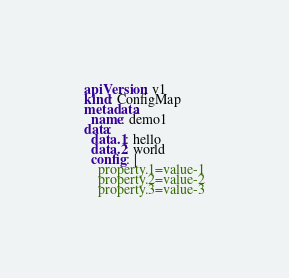<code> <loc_0><loc_0><loc_500><loc_500><_YAML_>apiVersion: v1
kind: ConfigMap
metadata:
  name: demo1
data:
  data.1: hello
  data.2: world
  config: |
    property.1=value-1
    property.2=value-2
    property.3=value-3</code> 